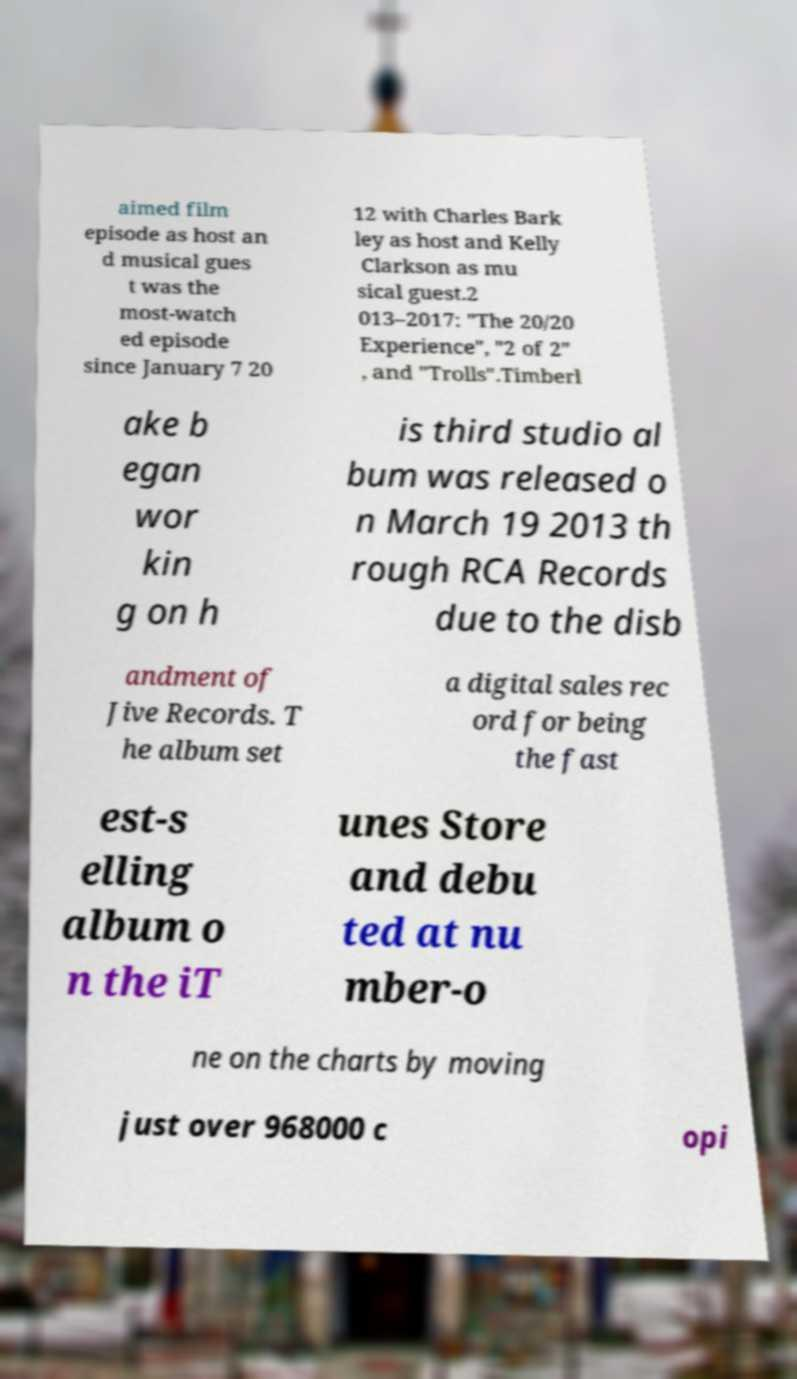Can you accurately transcribe the text from the provided image for me? aimed film episode as host an d musical gues t was the most-watch ed episode since January 7 20 12 with Charles Bark ley as host and Kelly Clarkson as mu sical guest.2 013–2017: "The 20/20 Experience", "2 of 2" , and "Trolls".Timberl ake b egan wor kin g on h is third studio al bum was released o n March 19 2013 th rough RCA Records due to the disb andment of Jive Records. T he album set a digital sales rec ord for being the fast est-s elling album o n the iT unes Store and debu ted at nu mber-o ne on the charts by moving just over 968000 c opi 